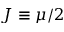<formula> <loc_0><loc_0><loc_500><loc_500>J \equiv \mu / 2</formula> 